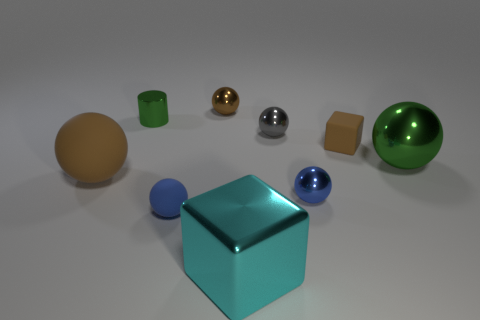Is the gray object made of the same material as the brown cube?
Your answer should be compact. No. There is a metallic thing that is the same color as the small cube; what is its size?
Your answer should be compact. Small. What material is the large sphere left of the brown shiny ball behind the green object on the right side of the cyan metal object made of?
Provide a succinct answer. Rubber. Is there a shiny ball that has the same color as the small cylinder?
Your response must be concise. Yes. Are there fewer tiny green shiny things left of the cyan object than large metal cubes?
Keep it short and to the point. No. Is the size of the brown thing left of the metallic cylinder the same as the cyan block?
Your answer should be very brief. Yes. How many things are to the right of the small brown metallic object and in front of the big brown rubber thing?
Your response must be concise. 2. How big is the green metallic thing that is right of the blue object that is to the right of the large cyan block?
Offer a terse response. Large. Are there fewer tiny gray objects that are behind the small green metallic object than tiny blue objects that are on the left side of the small gray sphere?
Ensure brevity in your answer.  Yes. Does the tiny matte thing on the left side of the brown shiny sphere have the same color as the tiny metal ball that is in front of the large green metallic object?
Offer a very short reply. Yes. 